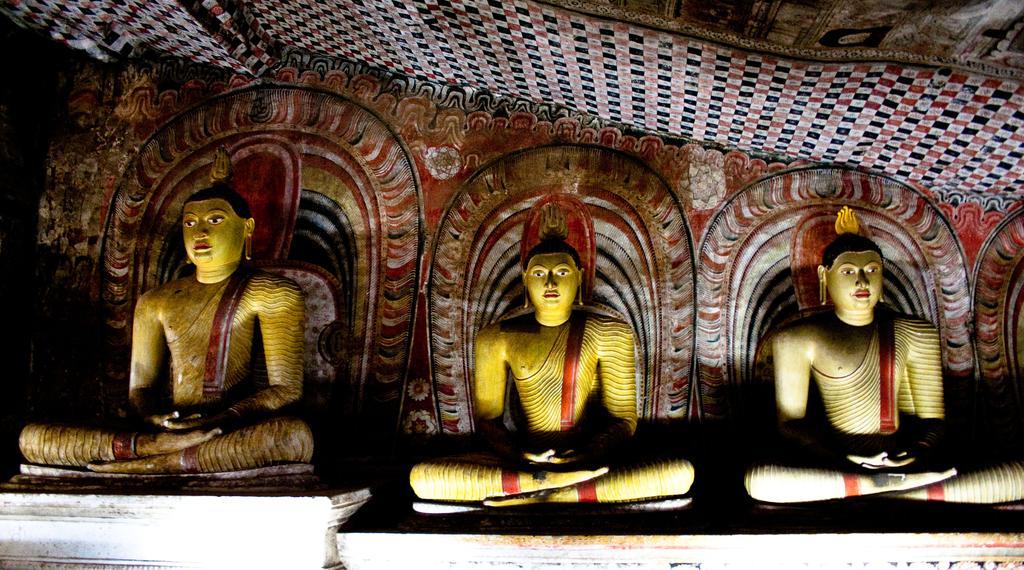Describe this image in one or two sentences. In this picture we can see three statues, it looks like a cloth at the top of the picture. 